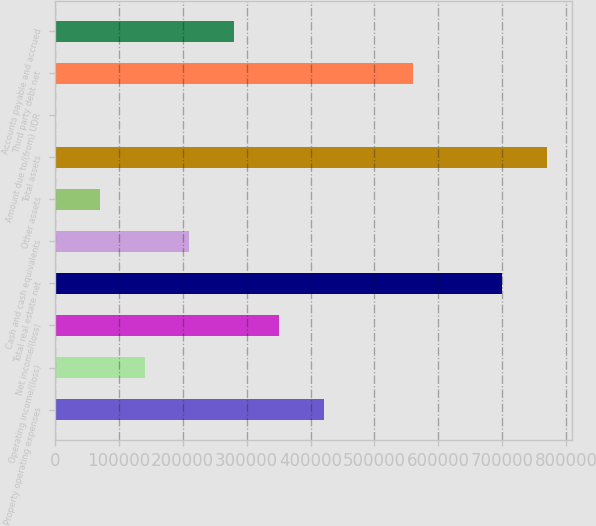Convert chart. <chart><loc_0><loc_0><loc_500><loc_500><bar_chart><fcel>Property operating expenses<fcel>Operating income/(loss)<fcel>Net income/(loss)<fcel>Total real estate net<fcel>Cash and cash equivalents<fcel>Other assets<fcel>Total assets<fcel>Amount due to/(from) UDR<fcel>Third party debt net<fcel>Accounts payable and accrued<nl><fcel>420392<fcel>140406<fcel>350396<fcel>700378<fcel>210402<fcel>70409.5<fcel>770374<fcel>413<fcel>560385<fcel>280399<nl></chart> 